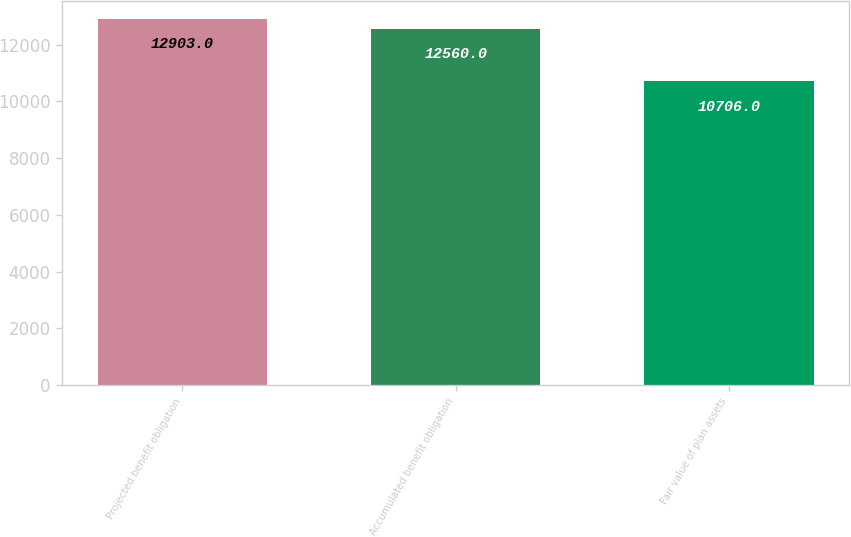Convert chart to OTSL. <chart><loc_0><loc_0><loc_500><loc_500><bar_chart><fcel>Projected benefit obligation<fcel>Accumulated benefit obligation<fcel>Fair value of plan assets<nl><fcel>12903<fcel>12560<fcel>10706<nl></chart> 